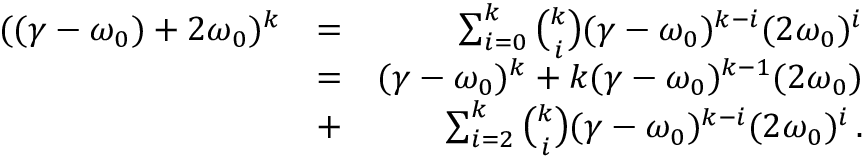Convert formula to latex. <formula><loc_0><loc_0><loc_500><loc_500>\begin{array} { r l r } { ( ( \gamma - \omega _ { 0 } ) + 2 \omega _ { 0 } ) ^ { k } } & { = } & { \sum _ { i = 0 } ^ { k } \binom { k } { i } ( \gamma - \omega _ { 0 } ) ^ { k - i } ( 2 \omega _ { 0 } ) ^ { i } } \\ & { = } & { ( \gamma - \omega _ { 0 } ) ^ { k } + k ( \gamma - \omega _ { 0 } ) ^ { k - 1 } ( 2 \omega _ { 0 } ) } \\ & { + } & { \sum _ { i = 2 } ^ { k } \binom { k } { i } ( \gamma - \omega _ { 0 } ) ^ { k - i } ( 2 \omega _ { 0 } ) ^ { i } \, . } \end{array}</formula> 